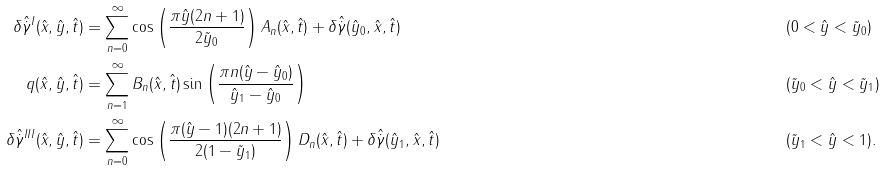<formula> <loc_0><loc_0><loc_500><loc_500>\delta \hat { \dot { \gamma } } ^ { I } ( \hat { x } , \hat { y } , \hat { t } ) & = \sum _ { n = 0 } ^ { \infty } \cos \left ( \frac { \pi \hat { y } ( 2 n + 1 ) } { 2 \tilde { y } _ { 0 } } \right ) A _ { n } ( \hat { x } , \hat { t } ) + \delta \hat { \dot { \gamma } } ( \hat { y } _ { 0 } , \hat { x } , \hat { t } ) & & ( 0 < \hat { y } < \tilde { y } _ { 0 } ) \\ q ( \hat { x } , \hat { y } , \hat { t } ) & = \sum _ { n = 1 } ^ { \infty } B _ { n } ( \hat { x } , \hat { t } ) \sin \left ( \frac { \pi n ( \hat { y } - \hat { y } _ { 0 } ) } { \hat { y } _ { 1 } - \hat { y } _ { 0 } } \right ) & & ( \tilde { y } _ { 0 } < \hat { y } < \tilde { y } _ { 1 } ) \\ \delta \hat { \dot { \gamma } } ^ { I I I } ( \hat { x } , \hat { y } , \hat { t } ) & = \sum _ { n = 0 } ^ { \infty } \cos \left ( \frac { \pi ( \hat { y } - 1 ) ( 2 n + 1 ) } { 2 ( 1 - \tilde { y } _ { 1 } ) } \right ) D _ { n } ( \hat { x } , \hat { t } ) + \delta \hat { \dot { \gamma } } ( \hat { y } _ { 1 } , \hat { x } , \hat { t } ) & & ( \tilde { y } _ { 1 } < \hat { y } < 1 ) .</formula> 